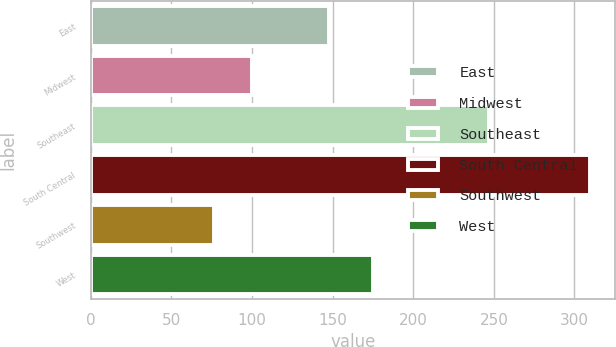<chart> <loc_0><loc_0><loc_500><loc_500><bar_chart><fcel>East<fcel>Midwest<fcel>Southeast<fcel>South Central<fcel>Southwest<fcel>West<nl><fcel>147.6<fcel>99.89<fcel>246.9<fcel>309.5<fcel>76.6<fcel>175<nl></chart> 